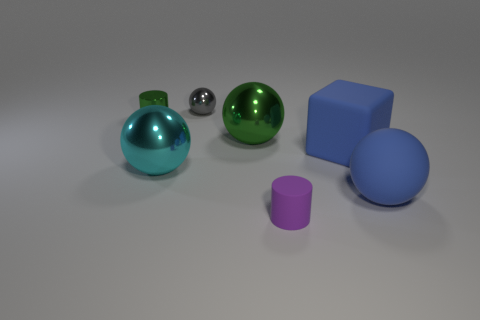Subtract 1 balls. How many balls are left? 3 Add 3 small gray shiny objects. How many objects exist? 10 Subtract all blocks. How many objects are left? 6 Subtract 0 gray cylinders. How many objects are left? 7 Subtract all big green rubber balls. Subtract all matte blocks. How many objects are left? 6 Add 2 blue matte spheres. How many blue matte spheres are left? 3 Add 3 blue rubber blocks. How many blue rubber blocks exist? 4 